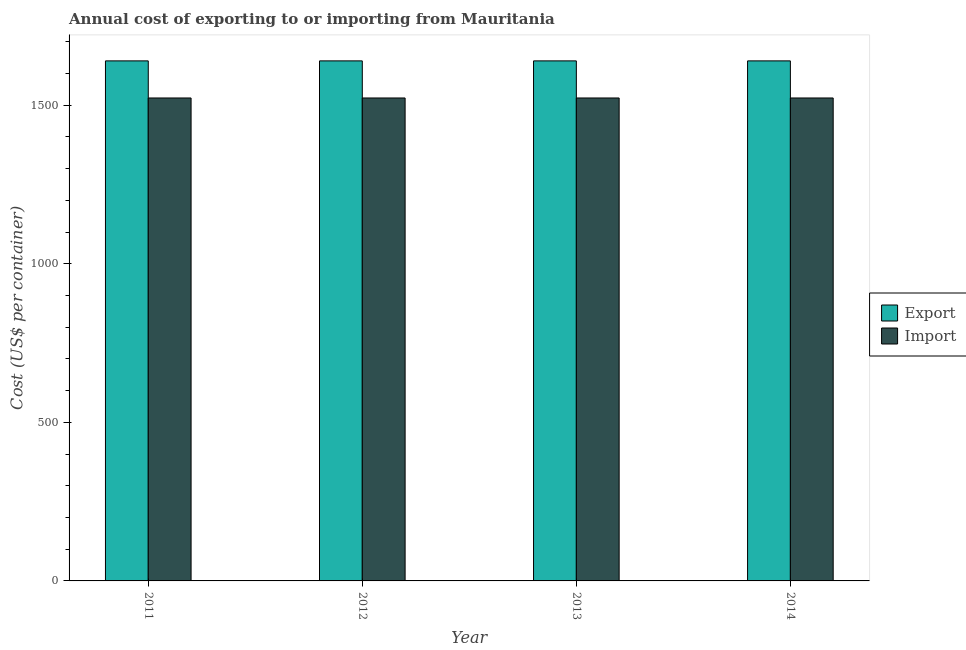How many different coloured bars are there?
Provide a succinct answer. 2. How many groups of bars are there?
Ensure brevity in your answer.  4. How many bars are there on the 2nd tick from the right?
Keep it short and to the point. 2. What is the label of the 3rd group of bars from the left?
Give a very brief answer. 2013. What is the export cost in 2013?
Your answer should be compact. 1640. Across all years, what is the maximum export cost?
Your answer should be very brief. 1640. Across all years, what is the minimum export cost?
Make the answer very short. 1640. In which year was the import cost maximum?
Offer a terse response. 2011. What is the total import cost in the graph?
Your response must be concise. 6092. What is the difference between the export cost in 2013 and that in 2014?
Make the answer very short. 0. What is the average import cost per year?
Offer a terse response. 1523. In the year 2014, what is the difference between the export cost and import cost?
Provide a succinct answer. 0. In how many years, is the import cost greater than 200 US$?
Give a very brief answer. 4. What is the ratio of the import cost in 2012 to that in 2014?
Your answer should be very brief. 1. Is the difference between the import cost in 2012 and 2013 greater than the difference between the export cost in 2012 and 2013?
Provide a short and direct response. No. In how many years, is the export cost greater than the average export cost taken over all years?
Your answer should be compact. 0. What does the 2nd bar from the left in 2014 represents?
Your answer should be very brief. Import. What does the 1st bar from the right in 2014 represents?
Your answer should be compact. Import. How many bars are there?
Offer a terse response. 8. Are all the bars in the graph horizontal?
Offer a terse response. No. How many years are there in the graph?
Your answer should be compact. 4. Are the values on the major ticks of Y-axis written in scientific E-notation?
Your answer should be very brief. No. Does the graph contain any zero values?
Offer a very short reply. No. Where does the legend appear in the graph?
Ensure brevity in your answer.  Center right. How many legend labels are there?
Ensure brevity in your answer.  2. How are the legend labels stacked?
Your response must be concise. Vertical. What is the title of the graph?
Give a very brief answer. Annual cost of exporting to or importing from Mauritania. Does "Taxes" appear as one of the legend labels in the graph?
Your answer should be compact. No. What is the label or title of the X-axis?
Ensure brevity in your answer.  Year. What is the label or title of the Y-axis?
Provide a short and direct response. Cost (US$ per container). What is the Cost (US$ per container) in Export in 2011?
Your response must be concise. 1640. What is the Cost (US$ per container) of Import in 2011?
Your answer should be very brief. 1523. What is the Cost (US$ per container) in Export in 2012?
Offer a very short reply. 1640. What is the Cost (US$ per container) in Import in 2012?
Ensure brevity in your answer.  1523. What is the Cost (US$ per container) in Export in 2013?
Keep it short and to the point. 1640. What is the Cost (US$ per container) of Import in 2013?
Your answer should be very brief. 1523. What is the Cost (US$ per container) of Export in 2014?
Make the answer very short. 1640. What is the Cost (US$ per container) of Import in 2014?
Offer a terse response. 1523. Across all years, what is the maximum Cost (US$ per container) in Export?
Provide a short and direct response. 1640. Across all years, what is the maximum Cost (US$ per container) of Import?
Your response must be concise. 1523. Across all years, what is the minimum Cost (US$ per container) in Export?
Your response must be concise. 1640. Across all years, what is the minimum Cost (US$ per container) of Import?
Your answer should be compact. 1523. What is the total Cost (US$ per container) in Export in the graph?
Your answer should be very brief. 6560. What is the total Cost (US$ per container) of Import in the graph?
Provide a short and direct response. 6092. What is the difference between the Cost (US$ per container) in Export in 2011 and that in 2012?
Provide a succinct answer. 0. What is the difference between the Cost (US$ per container) in Import in 2011 and that in 2013?
Your answer should be compact. 0. What is the difference between the Cost (US$ per container) of Export in 2011 and that in 2014?
Your response must be concise. 0. What is the difference between the Cost (US$ per container) in Import in 2011 and that in 2014?
Give a very brief answer. 0. What is the difference between the Cost (US$ per container) in Export in 2012 and that in 2013?
Offer a very short reply. 0. What is the difference between the Cost (US$ per container) of Export in 2012 and that in 2014?
Keep it short and to the point. 0. What is the difference between the Cost (US$ per container) of Export in 2013 and that in 2014?
Offer a very short reply. 0. What is the difference between the Cost (US$ per container) of Export in 2011 and the Cost (US$ per container) of Import in 2012?
Offer a very short reply. 117. What is the difference between the Cost (US$ per container) in Export in 2011 and the Cost (US$ per container) in Import in 2013?
Your answer should be very brief. 117. What is the difference between the Cost (US$ per container) in Export in 2011 and the Cost (US$ per container) in Import in 2014?
Your answer should be very brief. 117. What is the difference between the Cost (US$ per container) in Export in 2012 and the Cost (US$ per container) in Import in 2013?
Your answer should be compact. 117. What is the difference between the Cost (US$ per container) in Export in 2012 and the Cost (US$ per container) in Import in 2014?
Ensure brevity in your answer.  117. What is the difference between the Cost (US$ per container) in Export in 2013 and the Cost (US$ per container) in Import in 2014?
Your answer should be very brief. 117. What is the average Cost (US$ per container) of Export per year?
Provide a short and direct response. 1640. What is the average Cost (US$ per container) of Import per year?
Offer a terse response. 1523. In the year 2011, what is the difference between the Cost (US$ per container) of Export and Cost (US$ per container) of Import?
Ensure brevity in your answer.  117. In the year 2012, what is the difference between the Cost (US$ per container) of Export and Cost (US$ per container) of Import?
Your answer should be very brief. 117. In the year 2013, what is the difference between the Cost (US$ per container) of Export and Cost (US$ per container) of Import?
Ensure brevity in your answer.  117. In the year 2014, what is the difference between the Cost (US$ per container) of Export and Cost (US$ per container) of Import?
Offer a terse response. 117. What is the ratio of the Cost (US$ per container) of Export in 2011 to that in 2012?
Provide a short and direct response. 1. What is the ratio of the Cost (US$ per container) of Import in 2011 to that in 2012?
Your answer should be compact. 1. What is the ratio of the Cost (US$ per container) of Import in 2011 to that in 2013?
Offer a terse response. 1. What is the ratio of the Cost (US$ per container) of Import in 2012 to that in 2013?
Your answer should be compact. 1. What is the ratio of the Cost (US$ per container) of Export in 2012 to that in 2014?
Keep it short and to the point. 1. What is the ratio of the Cost (US$ per container) in Import in 2012 to that in 2014?
Give a very brief answer. 1. What is the ratio of the Cost (US$ per container) of Export in 2013 to that in 2014?
Ensure brevity in your answer.  1. What is the ratio of the Cost (US$ per container) in Import in 2013 to that in 2014?
Your response must be concise. 1. What is the difference between the highest and the second highest Cost (US$ per container) in Import?
Offer a very short reply. 0. 